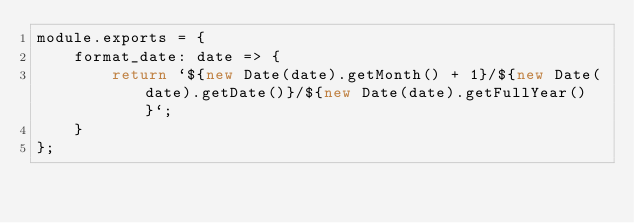<code> <loc_0><loc_0><loc_500><loc_500><_JavaScript_>module.exports = {
    format_date: date => {
        return `${new Date(date).getMonth() + 1}/${new Date(date).getDate()}/${new Date(date).getFullYear()}`;
    }
};</code> 